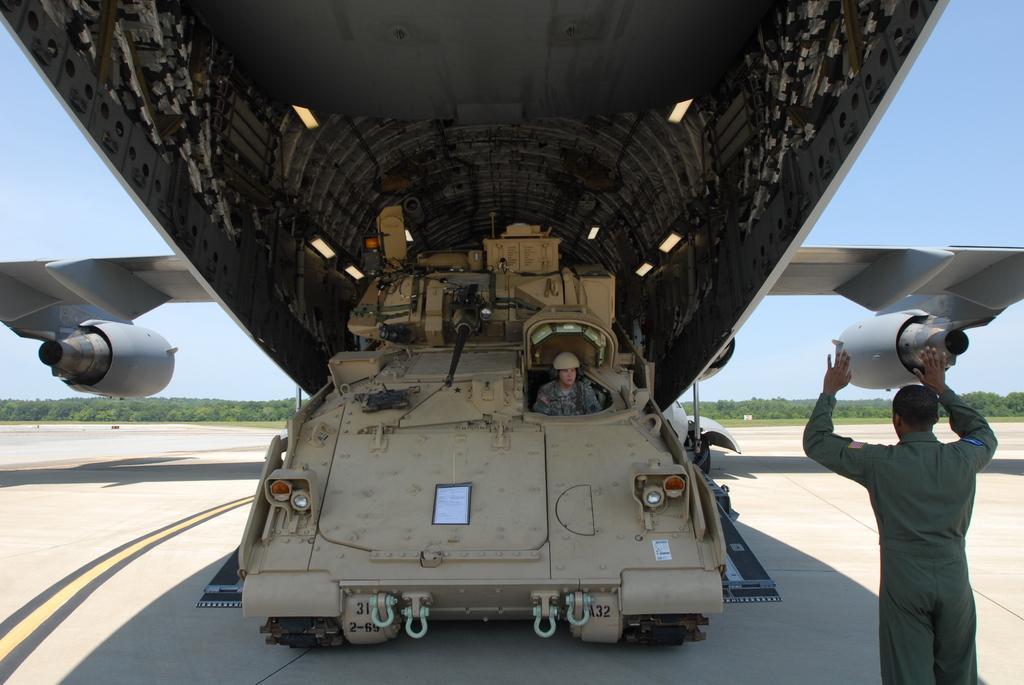Please provide a concise description of this image. In this image there is an aeroplane and we can see a vehicle. There is a person sitting in the vehicle. On the right there is a man. In the background there are trees and sky. 